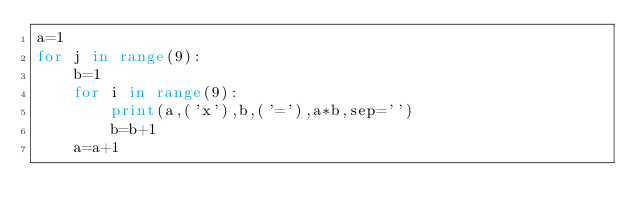Convert code to text. <code><loc_0><loc_0><loc_500><loc_500><_Python_>a=1
for j in range(9):
    b=1
    for i in range(9):
        print(a,('x'),b,('='),a*b,sep='')
        b=b+1
    a=a+1
</code> 